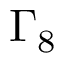<formula> <loc_0><loc_0><loc_500><loc_500>\Gamma _ { 8 }</formula> 